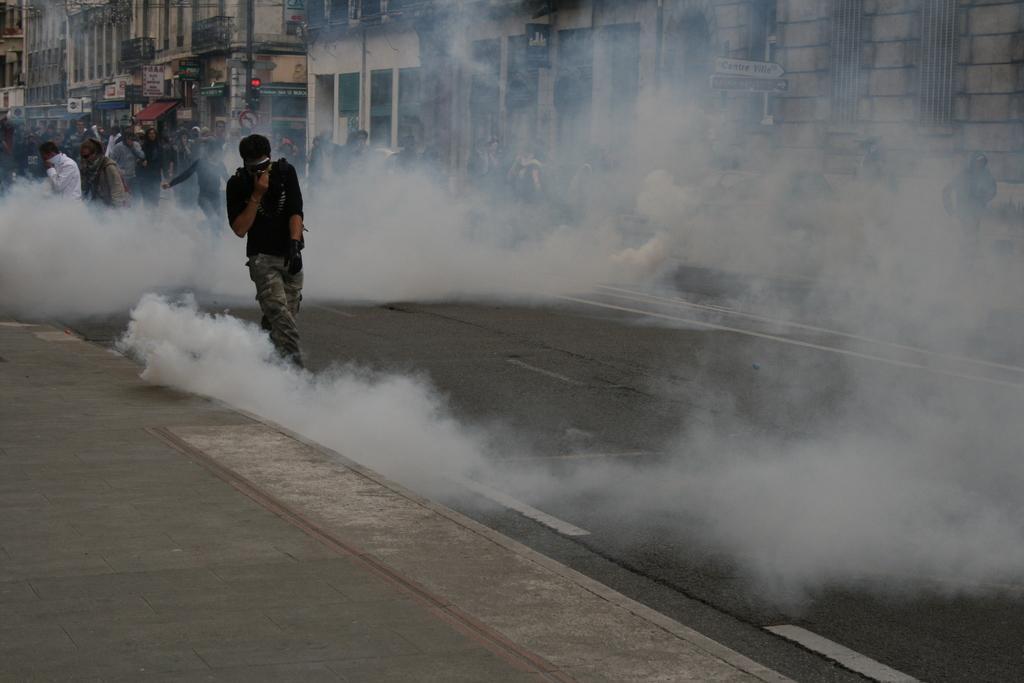Could you give a brief overview of what you see in this image? In the center of the image, we can see a person wearing gloves and glasses and in the background, there are some other people and we can see buildings, boards, a light and there is smoke. At the bottom, there is a road. 